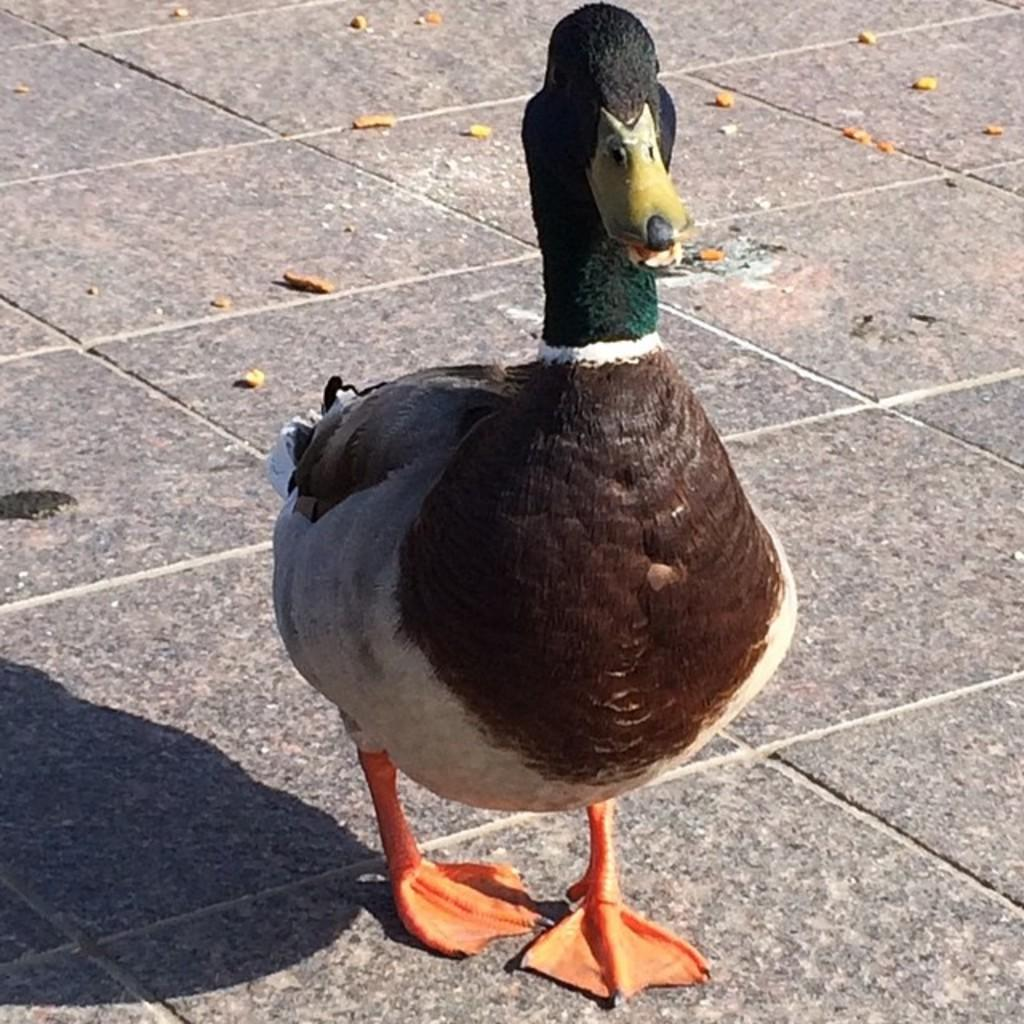What type of animal is present in the image? There is a duck in the image. What type of crayon is being used to draw a religious symbol on the duck's beak in the image? There is no crayon, religious symbol, or drawing on the duck's beak in the image. 